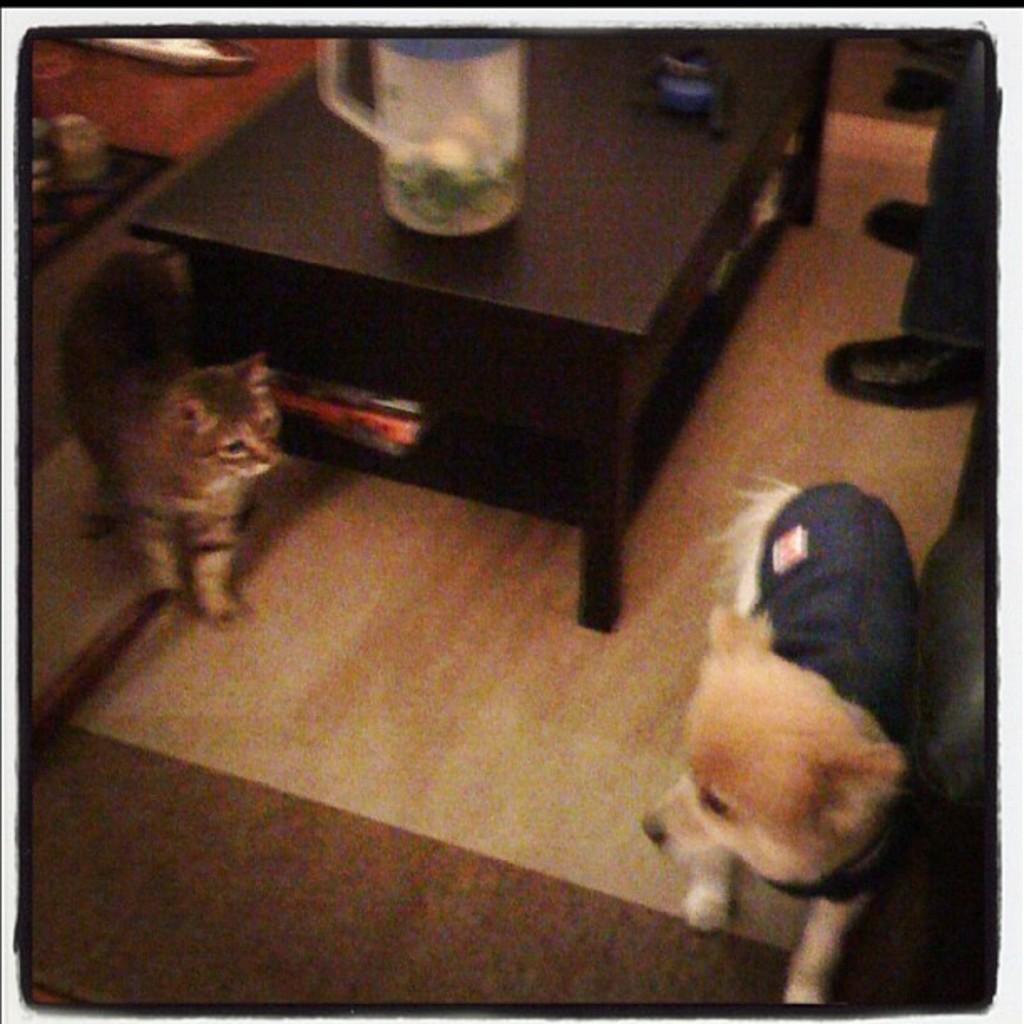Could you give a brief overview of what you see in this image? In this image there is a person at the right side of the image. There is a cat and dog in the image. There is a jug on the table. 